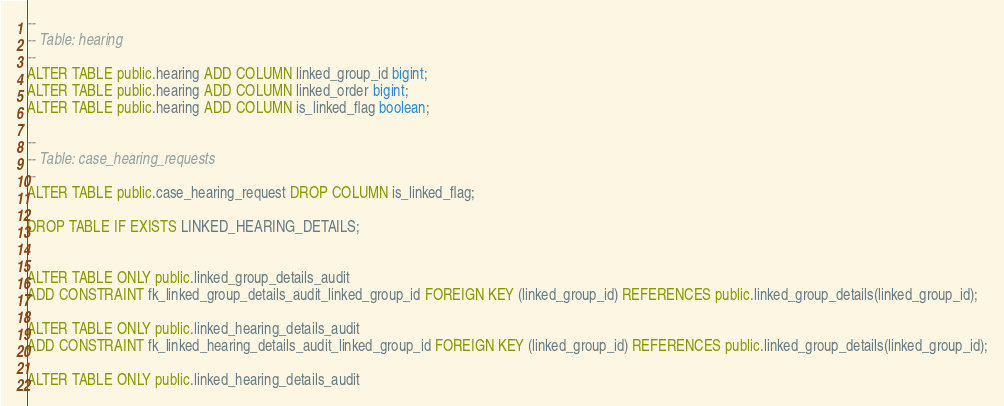<code> <loc_0><loc_0><loc_500><loc_500><_SQL_>--
-- Table: hearing
--
ALTER TABLE public.hearing ADD COLUMN linked_group_id bigint;
ALTER TABLE public.hearing ADD COLUMN linked_order bigint;
ALTER TABLE public.hearing ADD COLUMN is_linked_flag boolean;

--
-- Table: case_hearing_requests
--
ALTER TABLE public.case_hearing_request DROP COLUMN is_linked_flag;

DROP TABLE IF EXISTS LINKED_HEARING_DETAILS;


ALTER TABLE ONLY public.linked_group_details_audit
ADD CONSTRAINT fk_linked_group_details_audit_linked_group_id FOREIGN KEY (linked_group_id) REFERENCES public.linked_group_details(linked_group_id);

ALTER TABLE ONLY public.linked_hearing_details_audit
ADD CONSTRAINT fk_linked_hearing_details_audit_linked_group_id FOREIGN KEY (linked_group_id) REFERENCES public.linked_group_details(linked_group_id);

ALTER TABLE ONLY public.linked_hearing_details_audit</code> 